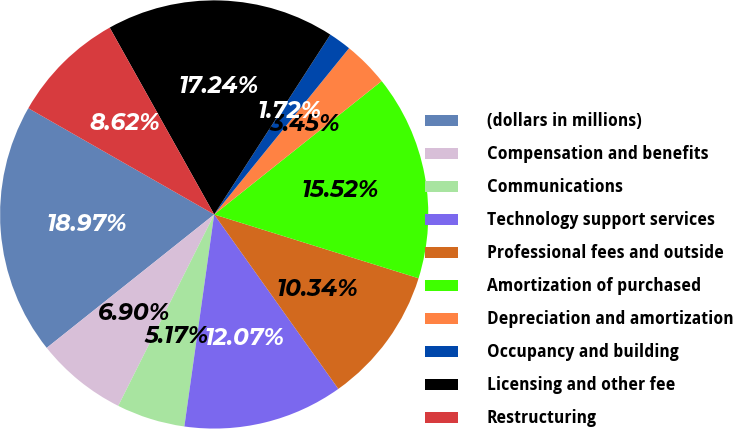Convert chart to OTSL. <chart><loc_0><loc_0><loc_500><loc_500><pie_chart><fcel>(dollars in millions)<fcel>Compensation and benefits<fcel>Communications<fcel>Technology support services<fcel>Professional fees and outside<fcel>Amortization of purchased<fcel>Depreciation and amortization<fcel>Occupancy and building<fcel>Licensing and other fee<fcel>Restructuring<nl><fcel>18.97%<fcel>6.9%<fcel>5.17%<fcel>12.07%<fcel>10.34%<fcel>15.52%<fcel>3.45%<fcel>1.72%<fcel>17.24%<fcel>8.62%<nl></chart> 